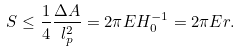Convert formula to latex. <formula><loc_0><loc_0><loc_500><loc_500>S \leq \frac { 1 } { 4 } \frac { \Delta A } { l _ { p } ^ { 2 } } = 2 \pi E H _ { 0 } ^ { - 1 } = 2 \pi E r .</formula> 